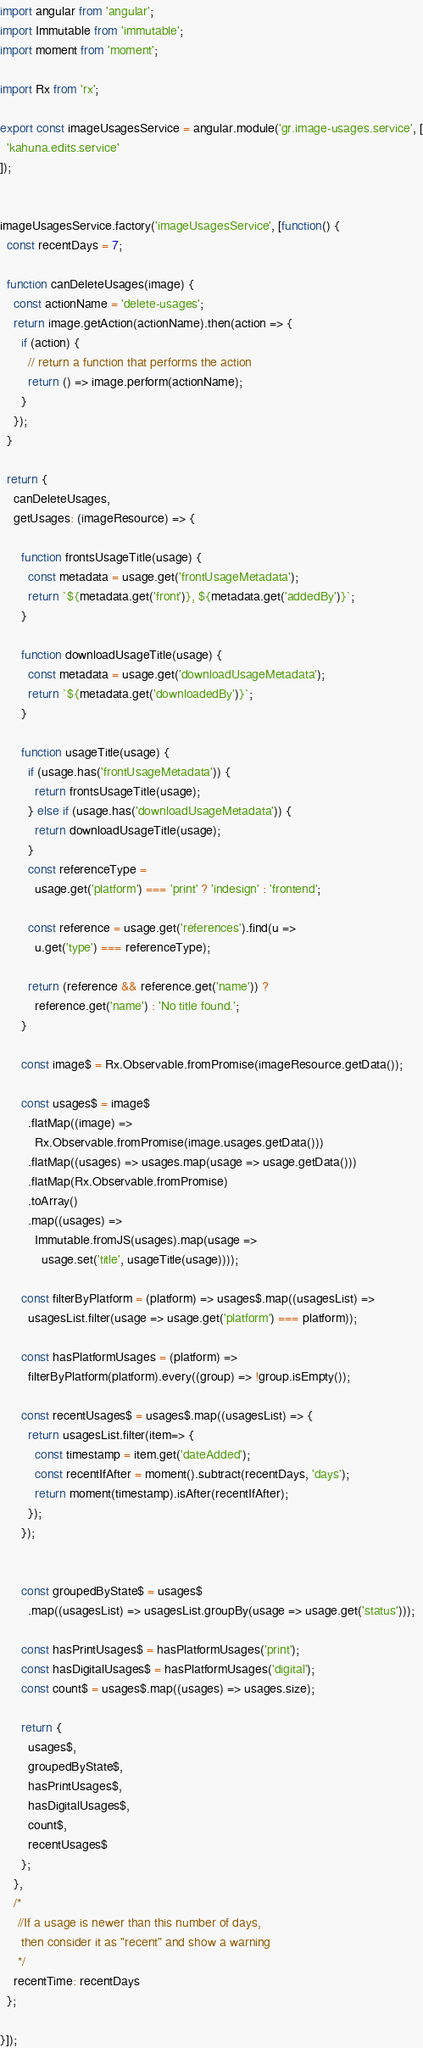<code> <loc_0><loc_0><loc_500><loc_500><_JavaScript_>import angular from 'angular';
import Immutable from 'immutable';
import moment from 'moment';

import Rx from 'rx';

export const imageUsagesService = angular.module('gr.image-usages.service', [
  'kahuna.edits.service'
]);


imageUsagesService.factory('imageUsagesService', [function() {
  const recentDays = 7;

  function canDeleteUsages(image) {
    const actionName = 'delete-usages';
    return image.getAction(actionName).then(action => {
      if (action) {
        // return a function that performs the action
        return () => image.perform(actionName);
      }
    });
  }

  return {
    canDeleteUsages,
    getUsages: (imageResource) => {

      function frontsUsageTitle(usage) {
        const metadata = usage.get('frontUsageMetadata');
        return `${metadata.get('front')}, ${metadata.get('addedBy')}`;
      }

      function downloadUsageTitle(usage) {
        const metadata = usage.get('downloadUsageMetadata');
        return `${metadata.get('downloadedBy')}`;
      }

      function usageTitle(usage) {
        if (usage.has('frontUsageMetadata')) {
          return frontsUsageTitle(usage);
        } else if (usage.has('downloadUsageMetadata')) {
          return downloadUsageTitle(usage);
        }
        const referenceType =
          usage.get('platform') === 'print' ? 'indesign' : 'frontend';

        const reference = usage.get('references').find(u =>
          u.get('type') === referenceType);

        return (reference && reference.get('name')) ?
          reference.get('name') : 'No title found.';
      }

      const image$ = Rx.Observable.fromPromise(imageResource.getData());

      const usages$ = image$
        .flatMap((image) =>
          Rx.Observable.fromPromise(image.usages.getData()))
        .flatMap((usages) => usages.map(usage => usage.getData()))
        .flatMap(Rx.Observable.fromPromise)
        .toArray()
        .map((usages) =>
          Immutable.fromJS(usages).map(usage =>
            usage.set('title', usageTitle(usage))));

      const filterByPlatform = (platform) => usages$.map((usagesList) =>
        usagesList.filter(usage => usage.get('platform') === platform));

      const hasPlatformUsages = (platform) =>
        filterByPlatform(platform).every((group) => !group.isEmpty());

      const recentUsages$ = usages$.map((usagesList) => {
        return usagesList.filter(item=> {
          const timestamp = item.get('dateAdded');
          const recentIfAfter = moment().subtract(recentDays, 'days');
          return moment(timestamp).isAfter(recentIfAfter);
        });
      });


      const groupedByState$ = usages$
        .map((usagesList) => usagesList.groupBy(usage => usage.get('status')));

      const hasPrintUsages$ = hasPlatformUsages('print');
      const hasDigitalUsages$ = hasPlatformUsages('digital');
      const count$ = usages$.map((usages) => usages.size);

      return {
        usages$,
        groupedByState$,
        hasPrintUsages$,
        hasDigitalUsages$,
        count$,
        recentUsages$
      };
    },
    /*
     //If a usage is newer than this number of days,
      then consider it as "recent" and show a warning
     */
    recentTime: recentDays
  };

}]);
</code> 